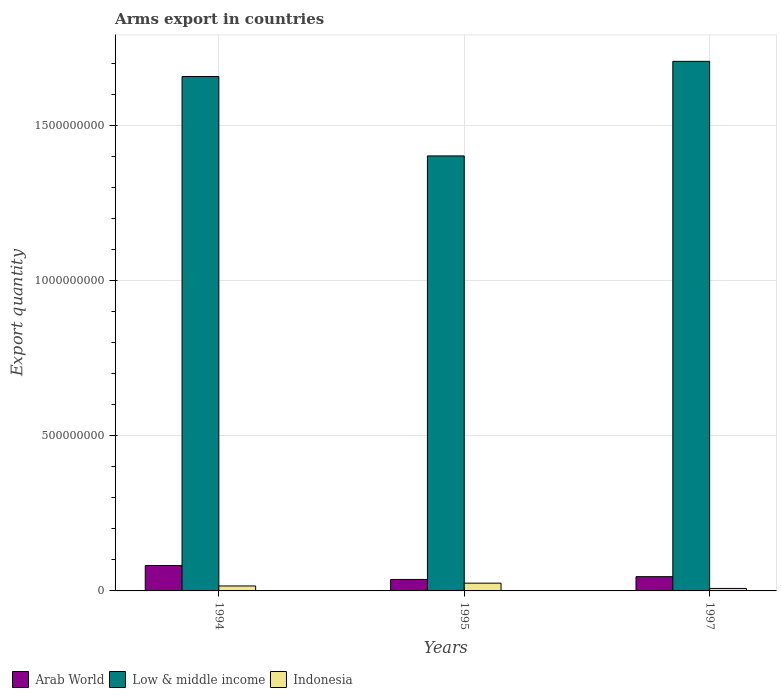How many groups of bars are there?
Give a very brief answer. 3. Are the number of bars per tick equal to the number of legend labels?
Keep it short and to the point. Yes. What is the total arms export in Indonesia in 1995?
Make the answer very short. 2.50e+07. Across all years, what is the maximum total arms export in Arab World?
Keep it short and to the point. 8.20e+07. What is the total total arms export in Arab World in the graph?
Provide a short and direct response. 1.65e+08. What is the difference between the total arms export in Indonesia in 1995 and that in 1997?
Provide a succinct answer. 1.70e+07. What is the difference between the total arms export in Indonesia in 1997 and the total arms export in Arab World in 1995?
Make the answer very short. -2.90e+07. What is the average total arms export in Low & middle income per year?
Your response must be concise. 1.59e+09. In the year 1995, what is the difference between the total arms export in Indonesia and total arms export in Arab World?
Provide a succinct answer. -1.20e+07. What is the ratio of the total arms export in Indonesia in 1994 to that in 1995?
Ensure brevity in your answer.  0.64. What is the difference between the highest and the second highest total arms export in Low & middle income?
Provide a short and direct response. 4.90e+07. What is the difference between the highest and the lowest total arms export in Indonesia?
Your response must be concise. 1.70e+07. In how many years, is the total arms export in Arab World greater than the average total arms export in Arab World taken over all years?
Keep it short and to the point. 1. What does the 1st bar from the left in 1994 represents?
Provide a short and direct response. Arab World. Is it the case that in every year, the sum of the total arms export in Indonesia and total arms export in Arab World is greater than the total arms export in Low & middle income?
Ensure brevity in your answer.  No. Are all the bars in the graph horizontal?
Offer a terse response. No. How many years are there in the graph?
Give a very brief answer. 3. What is the difference between two consecutive major ticks on the Y-axis?
Offer a terse response. 5.00e+08. Does the graph contain grids?
Your response must be concise. Yes. Where does the legend appear in the graph?
Your response must be concise. Bottom left. How many legend labels are there?
Provide a short and direct response. 3. What is the title of the graph?
Provide a succinct answer. Arms export in countries. Does "Djibouti" appear as one of the legend labels in the graph?
Give a very brief answer. No. What is the label or title of the Y-axis?
Offer a terse response. Export quantity. What is the Export quantity in Arab World in 1994?
Your response must be concise. 8.20e+07. What is the Export quantity in Low & middle income in 1994?
Your response must be concise. 1.66e+09. What is the Export quantity in Indonesia in 1994?
Give a very brief answer. 1.60e+07. What is the Export quantity of Arab World in 1995?
Offer a very short reply. 3.70e+07. What is the Export quantity in Low & middle income in 1995?
Give a very brief answer. 1.40e+09. What is the Export quantity of Indonesia in 1995?
Keep it short and to the point. 2.50e+07. What is the Export quantity of Arab World in 1997?
Make the answer very short. 4.60e+07. What is the Export quantity in Low & middle income in 1997?
Your response must be concise. 1.71e+09. Across all years, what is the maximum Export quantity in Arab World?
Provide a short and direct response. 8.20e+07. Across all years, what is the maximum Export quantity in Low & middle income?
Keep it short and to the point. 1.71e+09. Across all years, what is the maximum Export quantity in Indonesia?
Ensure brevity in your answer.  2.50e+07. Across all years, what is the minimum Export quantity in Arab World?
Your response must be concise. 3.70e+07. Across all years, what is the minimum Export quantity of Low & middle income?
Provide a short and direct response. 1.40e+09. Across all years, what is the minimum Export quantity in Indonesia?
Provide a short and direct response. 8.00e+06. What is the total Export quantity of Arab World in the graph?
Give a very brief answer. 1.65e+08. What is the total Export quantity in Low & middle income in the graph?
Your answer should be compact. 4.77e+09. What is the total Export quantity of Indonesia in the graph?
Your response must be concise. 4.90e+07. What is the difference between the Export quantity of Arab World in 1994 and that in 1995?
Provide a succinct answer. 4.50e+07. What is the difference between the Export quantity of Low & middle income in 1994 and that in 1995?
Your answer should be compact. 2.56e+08. What is the difference between the Export quantity of Indonesia in 1994 and that in 1995?
Provide a short and direct response. -9.00e+06. What is the difference between the Export quantity in Arab World in 1994 and that in 1997?
Ensure brevity in your answer.  3.60e+07. What is the difference between the Export quantity in Low & middle income in 1994 and that in 1997?
Provide a succinct answer. -4.90e+07. What is the difference between the Export quantity in Indonesia in 1994 and that in 1997?
Keep it short and to the point. 8.00e+06. What is the difference between the Export quantity in Arab World in 1995 and that in 1997?
Your answer should be compact. -9.00e+06. What is the difference between the Export quantity in Low & middle income in 1995 and that in 1997?
Your answer should be compact. -3.05e+08. What is the difference between the Export quantity in Indonesia in 1995 and that in 1997?
Provide a succinct answer. 1.70e+07. What is the difference between the Export quantity in Arab World in 1994 and the Export quantity in Low & middle income in 1995?
Offer a very short reply. -1.32e+09. What is the difference between the Export quantity in Arab World in 1994 and the Export quantity in Indonesia in 1995?
Give a very brief answer. 5.70e+07. What is the difference between the Export quantity in Low & middle income in 1994 and the Export quantity in Indonesia in 1995?
Your response must be concise. 1.63e+09. What is the difference between the Export quantity of Arab World in 1994 and the Export quantity of Low & middle income in 1997?
Give a very brief answer. -1.63e+09. What is the difference between the Export quantity in Arab World in 1994 and the Export quantity in Indonesia in 1997?
Offer a very short reply. 7.40e+07. What is the difference between the Export quantity of Low & middle income in 1994 and the Export quantity of Indonesia in 1997?
Your answer should be compact. 1.65e+09. What is the difference between the Export quantity of Arab World in 1995 and the Export quantity of Low & middle income in 1997?
Offer a terse response. -1.67e+09. What is the difference between the Export quantity in Arab World in 1995 and the Export quantity in Indonesia in 1997?
Your answer should be compact. 2.90e+07. What is the difference between the Export quantity in Low & middle income in 1995 and the Export quantity in Indonesia in 1997?
Give a very brief answer. 1.40e+09. What is the average Export quantity in Arab World per year?
Give a very brief answer. 5.50e+07. What is the average Export quantity in Low & middle income per year?
Ensure brevity in your answer.  1.59e+09. What is the average Export quantity in Indonesia per year?
Make the answer very short. 1.63e+07. In the year 1994, what is the difference between the Export quantity in Arab World and Export quantity in Low & middle income?
Your response must be concise. -1.58e+09. In the year 1994, what is the difference between the Export quantity in Arab World and Export quantity in Indonesia?
Ensure brevity in your answer.  6.60e+07. In the year 1994, what is the difference between the Export quantity of Low & middle income and Export quantity of Indonesia?
Your answer should be very brief. 1.64e+09. In the year 1995, what is the difference between the Export quantity of Arab World and Export quantity of Low & middle income?
Provide a succinct answer. -1.37e+09. In the year 1995, what is the difference between the Export quantity of Arab World and Export quantity of Indonesia?
Ensure brevity in your answer.  1.20e+07. In the year 1995, what is the difference between the Export quantity in Low & middle income and Export quantity in Indonesia?
Give a very brief answer. 1.38e+09. In the year 1997, what is the difference between the Export quantity in Arab World and Export quantity in Low & middle income?
Provide a short and direct response. -1.66e+09. In the year 1997, what is the difference between the Export quantity in Arab World and Export quantity in Indonesia?
Give a very brief answer. 3.80e+07. In the year 1997, what is the difference between the Export quantity in Low & middle income and Export quantity in Indonesia?
Offer a terse response. 1.70e+09. What is the ratio of the Export quantity in Arab World in 1994 to that in 1995?
Your response must be concise. 2.22. What is the ratio of the Export quantity of Low & middle income in 1994 to that in 1995?
Provide a short and direct response. 1.18. What is the ratio of the Export quantity in Indonesia in 1994 to that in 1995?
Make the answer very short. 0.64. What is the ratio of the Export quantity of Arab World in 1994 to that in 1997?
Provide a short and direct response. 1.78. What is the ratio of the Export quantity of Low & middle income in 1994 to that in 1997?
Provide a short and direct response. 0.97. What is the ratio of the Export quantity of Arab World in 1995 to that in 1997?
Your response must be concise. 0.8. What is the ratio of the Export quantity of Low & middle income in 1995 to that in 1997?
Give a very brief answer. 0.82. What is the ratio of the Export quantity of Indonesia in 1995 to that in 1997?
Keep it short and to the point. 3.12. What is the difference between the highest and the second highest Export quantity of Arab World?
Your response must be concise. 3.60e+07. What is the difference between the highest and the second highest Export quantity in Low & middle income?
Provide a succinct answer. 4.90e+07. What is the difference between the highest and the second highest Export quantity in Indonesia?
Your answer should be compact. 9.00e+06. What is the difference between the highest and the lowest Export quantity of Arab World?
Your answer should be very brief. 4.50e+07. What is the difference between the highest and the lowest Export quantity of Low & middle income?
Your answer should be very brief. 3.05e+08. What is the difference between the highest and the lowest Export quantity of Indonesia?
Ensure brevity in your answer.  1.70e+07. 